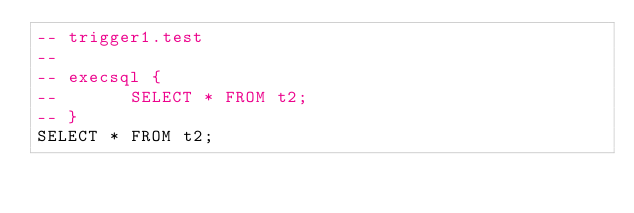<code> <loc_0><loc_0><loc_500><loc_500><_SQL_>-- trigger1.test
-- 
-- execsql {
--       SELECT * FROM t2;
-- }
SELECT * FROM t2;</code> 